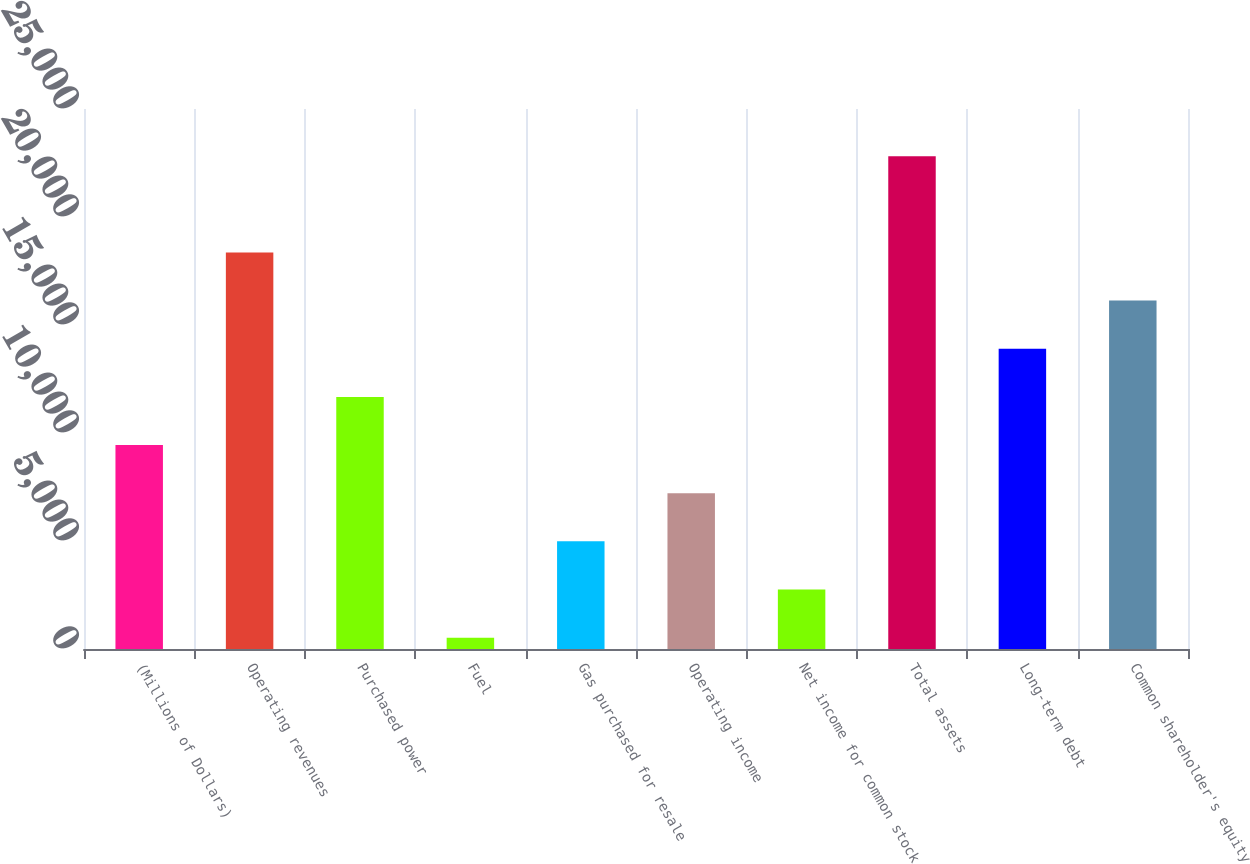Convert chart to OTSL. <chart><loc_0><loc_0><loc_500><loc_500><bar_chart><fcel>(Millions of Dollars)<fcel>Operating revenues<fcel>Purchased power<fcel>Fuel<fcel>Gas purchased for resale<fcel>Operating income<fcel>Net income for common stock<fcel>Total assets<fcel>Long-term debt<fcel>Common shareholder's equity<nl><fcel>9441.4<fcel>18357.8<fcel>11670.5<fcel>525<fcel>4983.2<fcel>7212.3<fcel>2754.1<fcel>22816<fcel>13899.6<fcel>16128.7<nl></chart> 